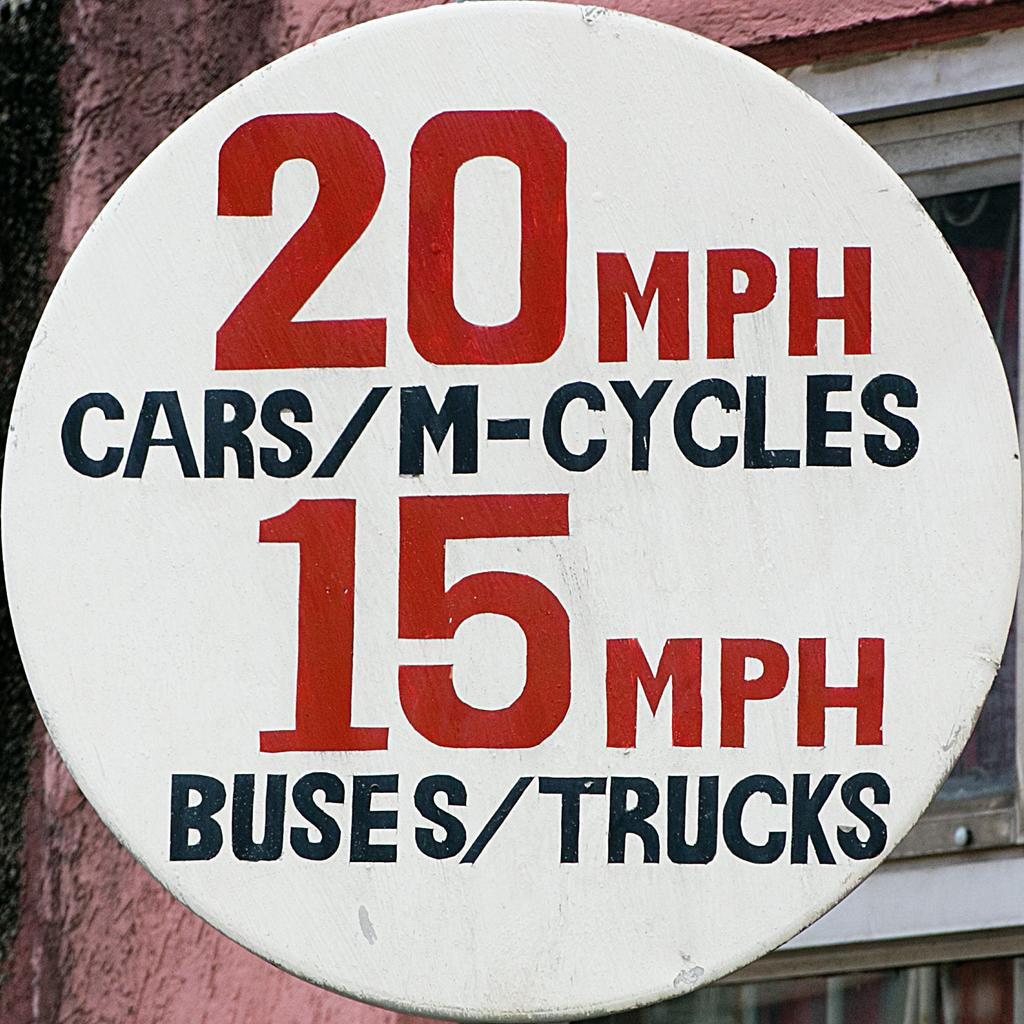<image>
Create a compact narrative representing the image presented. A circular sign says informs that cars should go 20mph and buses should go 15mph. 